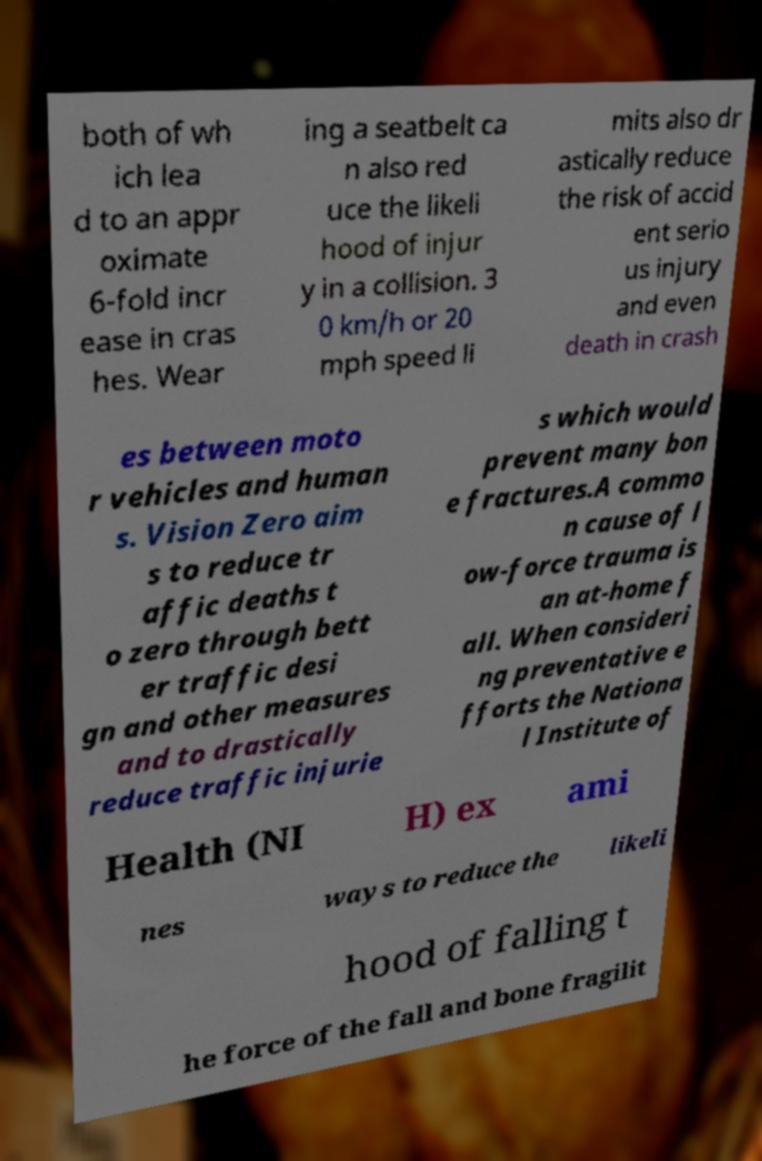Please identify and transcribe the text found in this image. both of wh ich lea d to an appr oximate 6-fold incr ease in cras hes. Wear ing a seatbelt ca n also red uce the likeli hood of injur y in a collision. 3 0 km/h or 20 mph speed li mits also dr astically reduce the risk of accid ent serio us injury and even death in crash es between moto r vehicles and human s. Vision Zero aim s to reduce tr affic deaths t o zero through bett er traffic desi gn and other measures and to drastically reduce traffic injurie s which would prevent many bon e fractures.A commo n cause of l ow-force trauma is an at-home f all. When consideri ng preventative e fforts the Nationa l Institute of Health (NI H) ex ami nes ways to reduce the likeli hood of falling t he force of the fall and bone fragilit 